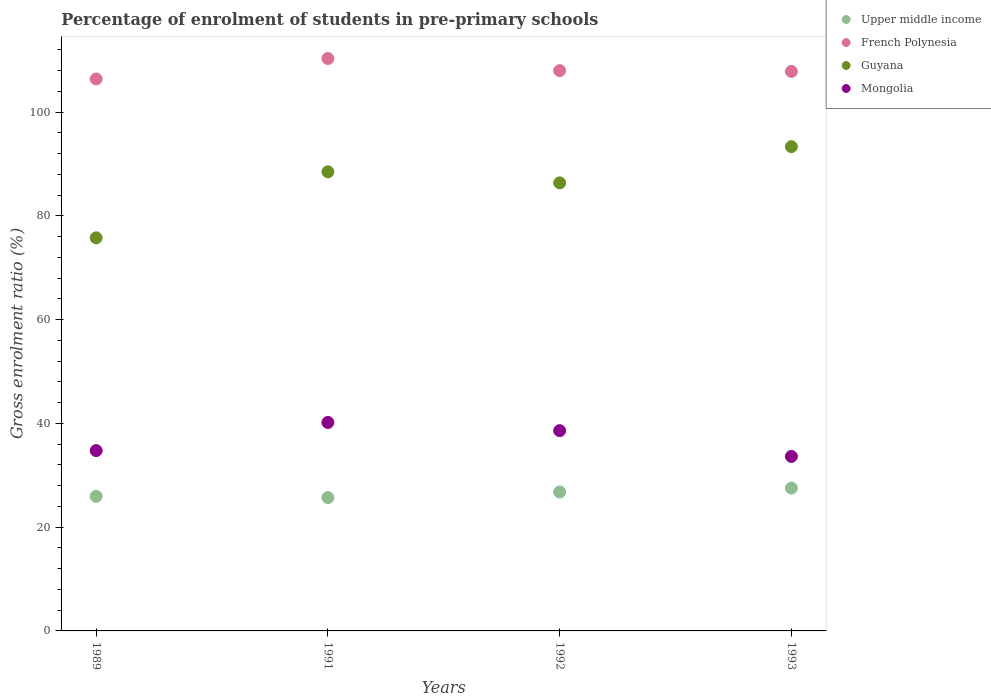How many different coloured dotlines are there?
Your answer should be compact. 4. Is the number of dotlines equal to the number of legend labels?
Your answer should be compact. Yes. What is the percentage of students enrolled in pre-primary schools in Upper middle income in 1989?
Offer a terse response. 25.94. Across all years, what is the maximum percentage of students enrolled in pre-primary schools in Upper middle income?
Ensure brevity in your answer.  27.53. Across all years, what is the minimum percentage of students enrolled in pre-primary schools in Guyana?
Provide a short and direct response. 75.77. In which year was the percentage of students enrolled in pre-primary schools in French Polynesia maximum?
Give a very brief answer. 1991. In which year was the percentage of students enrolled in pre-primary schools in French Polynesia minimum?
Make the answer very short. 1989. What is the total percentage of students enrolled in pre-primary schools in Upper middle income in the graph?
Your answer should be very brief. 105.95. What is the difference between the percentage of students enrolled in pre-primary schools in Upper middle income in 1991 and that in 1993?
Make the answer very short. -1.82. What is the difference between the percentage of students enrolled in pre-primary schools in Mongolia in 1993 and the percentage of students enrolled in pre-primary schools in Guyana in 1992?
Your response must be concise. -52.72. What is the average percentage of students enrolled in pre-primary schools in French Polynesia per year?
Your response must be concise. 108.14. In the year 1989, what is the difference between the percentage of students enrolled in pre-primary schools in French Polynesia and percentage of students enrolled in pre-primary schools in Guyana?
Ensure brevity in your answer.  30.62. In how many years, is the percentage of students enrolled in pre-primary schools in Guyana greater than 52 %?
Offer a very short reply. 4. What is the ratio of the percentage of students enrolled in pre-primary schools in Guyana in 1991 to that in 1993?
Provide a succinct answer. 0.95. What is the difference between the highest and the second highest percentage of students enrolled in pre-primary schools in Mongolia?
Your answer should be very brief. 1.58. What is the difference between the highest and the lowest percentage of students enrolled in pre-primary schools in French Polynesia?
Provide a succinct answer. 3.94. In how many years, is the percentage of students enrolled in pre-primary schools in Mongolia greater than the average percentage of students enrolled in pre-primary schools in Mongolia taken over all years?
Provide a succinct answer. 2. Is the sum of the percentage of students enrolled in pre-primary schools in Guyana in 1989 and 1991 greater than the maximum percentage of students enrolled in pre-primary schools in French Polynesia across all years?
Give a very brief answer. Yes. Does the percentage of students enrolled in pre-primary schools in French Polynesia monotonically increase over the years?
Give a very brief answer. No. How many years are there in the graph?
Offer a terse response. 4. What is the difference between two consecutive major ticks on the Y-axis?
Your response must be concise. 20. Are the values on the major ticks of Y-axis written in scientific E-notation?
Provide a succinct answer. No. How are the legend labels stacked?
Offer a terse response. Vertical. What is the title of the graph?
Provide a short and direct response. Percentage of enrolment of students in pre-primary schools. What is the Gross enrolment ratio (%) of Upper middle income in 1989?
Give a very brief answer. 25.94. What is the Gross enrolment ratio (%) in French Polynesia in 1989?
Provide a succinct answer. 106.39. What is the Gross enrolment ratio (%) in Guyana in 1989?
Your answer should be very brief. 75.77. What is the Gross enrolment ratio (%) of Mongolia in 1989?
Your answer should be compact. 34.76. What is the Gross enrolment ratio (%) in Upper middle income in 1991?
Offer a terse response. 25.71. What is the Gross enrolment ratio (%) of French Polynesia in 1991?
Your answer should be compact. 110.33. What is the Gross enrolment ratio (%) in Guyana in 1991?
Offer a terse response. 88.49. What is the Gross enrolment ratio (%) of Mongolia in 1991?
Make the answer very short. 40.18. What is the Gross enrolment ratio (%) in Upper middle income in 1992?
Your answer should be compact. 26.78. What is the Gross enrolment ratio (%) of French Polynesia in 1992?
Provide a short and direct response. 108. What is the Gross enrolment ratio (%) in Guyana in 1992?
Your answer should be very brief. 86.36. What is the Gross enrolment ratio (%) of Mongolia in 1992?
Provide a succinct answer. 38.6. What is the Gross enrolment ratio (%) in Upper middle income in 1993?
Your answer should be compact. 27.53. What is the Gross enrolment ratio (%) in French Polynesia in 1993?
Offer a very short reply. 107.84. What is the Gross enrolment ratio (%) in Guyana in 1993?
Provide a short and direct response. 93.34. What is the Gross enrolment ratio (%) in Mongolia in 1993?
Give a very brief answer. 33.64. Across all years, what is the maximum Gross enrolment ratio (%) of Upper middle income?
Make the answer very short. 27.53. Across all years, what is the maximum Gross enrolment ratio (%) in French Polynesia?
Your response must be concise. 110.33. Across all years, what is the maximum Gross enrolment ratio (%) in Guyana?
Make the answer very short. 93.34. Across all years, what is the maximum Gross enrolment ratio (%) of Mongolia?
Offer a very short reply. 40.18. Across all years, what is the minimum Gross enrolment ratio (%) of Upper middle income?
Provide a short and direct response. 25.71. Across all years, what is the minimum Gross enrolment ratio (%) in French Polynesia?
Your response must be concise. 106.39. Across all years, what is the minimum Gross enrolment ratio (%) in Guyana?
Give a very brief answer. 75.77. Across all years, what is the minimum Gross enrolment ratio (%) in Mongolia?
Ensure brevity in your answer.  33.64. What is the total Gross enrolment ratio (%) in Upper middle income in the graph?
Your response must be concise. 105.95. What is the total Gross enrolment ratio (%) of French Polynesia in the graph?
Your response must be concise. 432.56. What is the total Gross enrolment ratio (%) in Guyana in the graph?
Your answer should be very brief. 343.96. What is the total Gross enrolment ratio (%) of Mongolia in the graph?
Ensure brevity in your answer.  147.18. What is the difference between the Gross enrolment ratio (%) of Upper middle income in 1989 and that in 1991?
Your answer should be compact. 0.23. What is the difference between the Gross enrolment ratio (%) of French Polynesia in 1989 and that in 1991?
Your answer should be compact. -3.94. What is the difference between the Gross enrolment ratio (%) in Guyana in 1989 and that in 1991?
Provide a succinct answer. -12.72. What is the difference between the Gross enrolment ratio (%) of Mongolia in 1989 and that in 1991?
Ensure brevity in your answer.  -5.42. What is the difference between the Gross enrolment ratio (%) in Upper middle income in 1989 and that in 1992?
Ensure brevity in your answer.  -0.84. What is the difference between the Gross enrolment ratio (%) of French Polynesia in 1989 and that in 1992?
Ensure brevity in your answer.  -1.61. What is the difference between the Gross enrolment ratio (%) of Guyana in 1989 and that in 1992?
Give a very brief answer. -10.59. What is the difference between the Gross enrolment ratio (%) in Mongolia in 1989 and that in 1992?
Ensure brevity in your answer.  -3.84. What is the difference between the Gross enrolment ratio (%) of Upper middle income in 1989 and that in 1993?
Offer a terse response. -1.59. What is the difference between the Gross enrolment ratio (%) in French Polynesia in 1989 and that in 1993?
Your response must be concise. -1.46. What is the difference between the Gross enrolment ratio (%) in Guyana in 1989 and that in 1993?
Provide a short and direct response. -17.57. What is the difference between the Gross enrolment ratio (%) in Mongolia in 1989 and that in 1993?
Keep it short and to the point. 1.12. What is the difference between the Gross enrolment ratio (%) in Upper middle income in 1991 and that in 1992?
Provide a succinct answer. -1.07. What is the difference between the Gross enrolment ratio (%) of French Polynesia in 1991 and that in 1992?
Offer a very short reply. 2.33. What is the difference between the Gross enrolment ratio (%) in Guyana in 1991 and that in 1992?
Offer a terse response. 2.13. What is the difference between the Gross enrolment ratio (%) in Mongolia in 1991 and that in 1992?
Keep it short and to the point. 1.58. What is the difference between the Gross enrolment ratio (%) of Upper middle income in 1991 and that in 1993?
Your response must be concise. -1.82. What is the difference between the Gross enrolment ratio (%) in French Polynesia in 1991 and that in 1993?
Provide a short and direct response. 2.49. What is the difference between the Gross enrolment ratio (%) of Guyana in 1991 and that in 1993?
Provide a short and direct response. -4.85. What is the difference between the Gross enrolment ratio (%) of Mongolia in 1991 and that in 1993?
Offer a very short reply. 6.54. What is the difference between the Gross enrolment ratio (%) of Upper middle income in 1992 and that in 1993?
Give a very brief answer. -0.75. What is the difference between the Gross enrolment ratio (%) in French Polynesia in 1992 and that in 1993?
Keep it short and to the point. 0.16. What is the difference between the Gross enrolment ratio (%) of Guyana in 1992 and that in 1993?
Ensure brevity in your answer.  -6.98. What is the difference between the Gross enrolment ratio (%) of Mongolia in 1992 and that in 1993?
Provide a succinct answer. 4.97. What is the difference between the Gross enrolment ratio (%) of Upper middle income in 1989 and the Gross enrolment ratio (%) of French Polynesia in 1991?
Offer a very short reply. -84.39. What is the difference between the Gross enrolment ratio (%) of Upper middle income in 1989 and the Gross enrolment ratio (%) of Guyana in 1991?
Your answer should be very brief. -62.55. What is the difference between the Gross enrolment ratio (%) in Upper middle income in 1989 and the Gross enrolment ratio (%) in Mongolia in 1991?
Your answer should be very brief. -14.24. What is the difference between the Gross enrolment ratio (%) in French Polynesia in 1989 and the Gross enrolment ratio (%) in Guyana in 1991?
Offer a very short reply. 17.89. What is the difference between the Gross enrolment ratio (%) in French Polynesia in 1989 and the Gross enrolment ratio (%) in Mongolia in 1991?
Give a very brief answer. 66.21. What is the difference between the Gross enrolment ratio (%) of Guyana in 1989 and the Gross enrolment ratio (%) of Mongolia in 1991?
Your answer should be very brief. 35.59. What is the difference between the Gross enrolment ratio (%) in Upper middle income in 1989 and the Gross enrolment ratio (%) in French Polynesia in 1992?
Give a very brief answer. -82.06. What is the difference between the Gross enrolment ratio (%) in Upper middle income in 1989 and the Gross enrolment ratio (%) in Guyana in 1992?
Offer a very short reply. -60.42. What is the difference between the Gross enrolment ratio (%) of Upper middle income in 1989 and the Gross enrolment ratio (%) of Mongolia in 1992?
Give a very brief answer. -12.66. What is the difference between the Gross enrolment ratio (%) of French Polynesia in 1989 and the Gross enrolment ratio (%) of Guyana in 1992?
Your answer should be very brief. 20.03. What is the difference between the Gross enrolment ratio (%) of French Polynesia in 1989 and the Gross enrolment ratio (%) of Mongolia in 1992?
Your response must be concise. 67.79. What is the difference between the Gross enrolment ratio (%) of Guyana in 1989 and the Gross enrolment ratio (%) of Mongolia in 1992?
Ensure brevity in your answer.  37.17. What is the difference between the Gross enrolment ratio (%) of Upper middle income in 1989 and the Gross enrolment ratio (%) of French Polynesia in 1993?
Provide a short and direct response. -81.9. What is the difference between the Gross enrolment ratio (%) of Upper middle income in 1989 and the Gross enrolment ratio (%) of Guyana in 1993?
Provide a succinct answer. -67.4. What is the difference between the Gross enrolment ratio (%) of Upper middle income in 1989 and the Gross enrolment ratio (%) of Mongolia in 1993?
Provide a succinct answer. -7.7. What is the difference between the Gross enrolment ratio (%) in French Polynesia in 1989 and the Gross enrolment ratio (%) in Guyana in 1993?
Make the answer very short. 13.05. What is the difference between the Gross enrolment ratio (%) in French Polynesia in 1989 and the Gross enrolment ratio (%) in Mongolia in 1993?
Provide a succinct answer. 72.75. What is the difference between the Gross enrolment ratio (%) in Guyana in 1989 and the Gross enrolment ratio (%) in Mongolia in 1993?
Offer a terse response. 42.13. What is the difference between the Gross enrolment ratio (%) in Upper middle income in 1991 and the Gross enrolment ratio (%) in French Polynesia in 1992?
Your answer should be very brief. -82.29. What is the difference between the Gross enrolment ratio (%) of Upper middle income in 1991 and the Gross enrolment ratio (%) of Guyana in 1992?
Provide a short and direct response. -60.65. What is the difference between the Gross enrolment ratio (%) in Upper middle income in 1991 and the Gross enrolment ratio (%) in Mongolia in 1992?
Your answer should be very brief. -12.9. What is the difference between the Gross enrolment ratio (%) of French Polynesia in 1991 and the Gross enrolment ratio (%) of Guyana in 1992?
Ensure brevity in your answer.  23.97. What is the difference between the Gross enrolment ratio (%) in French Polynesia in 1991 and the Gross enrolment ratio (%) in Mongolia in 1992?
Ensure brevity in your answer.  71.73. What is the difference between the Gross enrolment ratio (%) in Guyana in 1991 and the Gross enrolment ratio (%) in Mongolia in 1992?
Ensure brevity in your answer.  49.89. What is the difference between the Gross enrolment ratio (%) of Upper middle income in 1991 and the Gross enrolment ratio (%) of French Polynesia in 1993?
Offer a terse response. -82.14. What is the difference between the Gross enrolment ratio (%) in Upper middle income in 1991 and the Gross enrolment ratio (%) in Guyana in 1993?
Ensure brevity in your answer.  -67.64. What is the difference between the Gross enrolment ratio (%) of Upper middle income in 1991 and the Gross enrolment ratio (%) of Mongolia in 1993?
Offer a terse response. -7.93. What is the difference between the Gross enrolment ratio (%) of French Polynesia in 1991 and the Gross enrolment ratio (%) of Guyana in 1993?
Make the answer very short. 16.99. What is the difference between the Gross enrolment ratio (%) of French Polynesia in 1991 and the Gross enrolment ratio (%) of Mongolia in 1993?
Your answer should be very brief. 76.69. What is the difference between the Gross enrolment ratio (%) of Guyana in 1991 and the Gross enrolment ratio (%) of Mongolia in 1993?
Your answer should be very brief. 54.86. What is the difference between the Gross enrolment ratio (%) of Upper middle income in 1992 and the Gross enrolment ratio (%) of French Polynesia in 1993?
Offer a very short reply. -81.07. What is the difference between the Gross enrolment ratio (%) in Upper middle income in 1992 and the Gross enrolment ratio (%) in Guyana in 1993?
Your answer should be compact. -66.56. What is the difference between the Gross enrolment ratio (%) in Upper middle income in 1992 and the Gross enrolment ratio (%) in Mongolia in 1993?
Your answer should be very brief. -6.86. What is the difference between the Gross enrolment ratio (%) in French Polynesia in 1992 and the Gross enrolment ratio (%) in Guyana in 1993?
Keep it short and to the point. 14.66. What is the difference between the Gross enrolment ratio (%) in French Polynesia in 1992 and the Gross enrolment ratio (%) in Mongolia in 1993?
Provide a short and direct response. 74.36. What is the difference between the Gross enrolment ratio (%) in Guyana in 1992 and the Gross enrolment ratio (%) in Mongolia in 1993?
Your answer should be very brief. 52.72. What is the average Gross enrolment ratio (%) of Upper middle income per year?
Keep it short and to the point. 26.49. What is the average Gross enrolment ratio (%) in French Polynesia per year?
Offer a very short reply. 108.14. What is the average Gross enrolment ratio (%) in Guyana per year?
Your answer should be compact. 85.99. What is the average Gross enrolment ratio (%) of Mongolia per year?
Make the answer very short. 36.79. In the year 1989, what is the difference between the Gross enrolment ratio (%) in Upper middle income and Gross enrolment ratio (%) in French Polynesia?
Provide a short and direct response. -80.45. In the year 1989, what is the difference between the Gross enrolment ratio (%) in Upper middle income and Gross enrolment ratio (%) in Guyana?
Ensure brevity in your answer.  -49.83. In the year 1989, what is the difference between the Gross enrolment ratio (%) in Upper middle income and Gross enrolment ratio (%) in Mongolia?
Provide a succinct answer. -8.82. In the year 1989, what is the difference between the Gross enrolment ratio (%) in French Polynesia and Gross enrolment ratio (%) in Guyana?
Ensure brevity in your answer.  30.62. In the year 1989, what is the difference between the Gross enrolment ratio (%) in French Polynesia and Gross enrolment ratio (%) in Mongolia?
Make the answer very short. 71.63. In the year 1989, what is the difference between the Gross enrolment ratio (%) in Guyana and Gross enrolment ratio (%) in Mongolia?
Your answer should be compact. 41.01. In the year 1991, what is the difference between the Gross enrolment ratio (%) of Upper middle income and Gross enrolment ratio (%) of French Polynesia?
Ensure brevity in your answer.  -84.63. In the year 1991, what is the difference between the Gross enrolment ratio (%) in Upper middle income and Gross enrolment ratio (%) in Guyana?
Provide a short and direct response. -62.79. In the year 1991, what is the difference between the Gross enrolment ratio (%) of Upper middle income and Gross enrolment ratio (%) of Mongolia?
Your response must be concise. -14.47. In the year 1991, what is the difference between the Gross enrolment ratio (%) of French Polynesia and Gross enrolment ratio (%) of Guyana?
Keep it short and to the point. 21.84. In the year 1991, what is the difference between the Gross enrolment ratio (%) in French Polynesia and Gross enrolment ratio (%) in Mongolia?
Your answer should be very brief. 70.15. In the year 1991, what is the difference between the Gross enrolment ratio (%) in Guyana and Gross enrolment ratio (%) in Mongolia?
Provide a short and direct response. 48.31. In the year 1992, what is the difference between the Gross enrolment ratio (%) of Upper middle income and Gross enrolment ratio (%) of French Polynesia?
Ensure brevity in your answer.  -81.22. In the year 1992, what is the difference between the Gross enrolment ratio (%) in Upper middle income and Gross enrolment ratio (%) in Guyana?
Your response must be concise. -59.58. In the year 1992, what is the difference between the Gross enrolment ratio (%) of Upper middle income and Gross enrolment ratio (%) of Mongolia?
Your answer should be compact. -11.82. In the year 1992, what is the difference between the Gross enrolment ratio (%) of French Polynesia and Gross enrolment ratio (%) of Guyana?
Your answer should be very brief. 21.64. In the year 1992, what is the difference between the Gross enrolment ratio (%) of French Polynesia and Gross enrolment ratio (%) of Mongolia?
Provide a succinct answer. 69.4. In the year 1992, what is the difference between the Gross enrolment ratio (%) of Guyana and Gross enrolment ratio (%) of Mongolia?
Your answer should be very brief. 47.76. In the year 1993, what is the difference between the Gross enrolment ratio (%) in Upper middle income and Gross enrolment ratio (%) in French Polynesia?
Ensure brevity in your answer.  -80.31. In the year 1993, what is the difference between the Gross enrolment ratio (%) in Upper middle income and Gross enrolment ratio (%) in Guyana?
Provide a succinct answer. -65.81. In the year 1993, what is the difference between the Gross enrolment ratio (%) in Upper middle income and Gross enrolment ratio (%) in Mongolia?
Your response must be concise. -6.11. In the year 1993, what is the difference between the Gross enrolment ratio (%) of French Polynesia and Gross enrolment ratio (%) of Guyana?
Your answer should be very brief. 14.5. In the year 1993, what is the difference between the Gross enrolment ratio (%) in French Polynesia and Gross enrolment ratio (%) in Mongolia?
Your answer should be compact. 74.21. In the year 1993, what is the difference between the Gross enrolment ratio (%) in Guyana and Gross enrolment ratio (%) in Mongolia?
Provide a short and direct response. 59.7. What is the ratio of the Gross enrolment ratio (%) in Upper middle income in 1989 to that in 1991?
Keep it short and to the point. 1.01. What is the ratio of the Gross enrolment ratio (%) of French Polynesia in 1989 to that in 1991?
Give a very brief answer. 0.96. What is the ratio of the Gross enrolment ratio (%) in Guyana in 1989 to that in 1991?
Ensure brevity in your answer.  0.86. What is the ratio of the Gross enrolment ratio (%) of Mongolia in 1989 to that in 1991?
Offer a very short reply. 0.87. What is the ratio of the Gross enrolment ratio (%) of Upper middle income in 1989 to that in 1992?
Provide a succinct answer. 0.97. What is the ratio of the Gross enrolment ratio (%) in French Polynesia in 1989 to that in 1992?
Ensure brevity in your answer.  0.99. What is the ratio of the Gross enrolment ratio (%) of Guyana in 1989 to that in 1992?
Provide a succinct answer. 0.88. What is the ratio of the Gross enrolment ratio (%) of Mongolia in 1989 to that in 1992?
Your answer should be very brief. 0.9. What is the ratio of the Gross enrolment ratio (%) in Upper middle income in 1989 to that in 1993?
Provide a short and direct response. 0.94. What is the ratio of the Gross enrolment ratio (%) in French Polynesia in 1989 to that in 1993?
Make the answer very short. 0.99. What is the ratio of the Gross enrolment ratio (%) in Guyana in 1989 to that in 1993?
Keep it short and to the point. 0.81. What is the ratio of the Gross enrolment ratio (%) of Mongolia in 1989 to that in 1993?
Offer a terse response. 1.03. What is the ratio of the Gross enrolment ratio (%) of Upper middle income in 1991 to that in 1992?
Your answer should be very brief. 0.96. What is the ratio of the Gross enrolment ratio (%) in French Polynesia in 1991 to that in 1992?
Keep it short and to the point. 1.02. What is the ratio of the Gross enrolment ratio (%) of Guyana in 1991 to that in 1992?
Make the answer very short. 1.02. What is the ratio of the Gross enrolment ratio (%) of Mongolia in 1991 to that in 1992?
Provide a succinct answer. 1.04. What is the ratio of the Gross enrolment ratio (%) in Upper middle income in 1991 to that in 1993?
Your answer should be compact. 0.93. What is the ratio of the Gross enrolment ratio (%) in French Polynesia in 1991 to that in 1993?
Ensure brevity in your answer.  1.02. What is the ratio of the Gross enrolment ratio (%) in Guyana in 1991 to that in 1993?
Provide a succinct answer. 0.95. What is the ratio of the Gross enrolment ratio (%) in Mongolia in 1991 to that in 1993?
Make the answer very short. 1.19. What is the ratio of the Gross enrolment ratio (%) of Upper middle income in 1992 to that in 1993?
Make the answer very short. 0.97. What is the ratio of the Gross enrolment ratio (%) of Guyana in 1992 to that in 1993?
Your answer should be very brief. 0.93. What is the ratio of the Gross enrolment ratio (%) of Mongolia in 1992 to that in 1993?
Give a very brief answer. 1.15. What is the difference between the highest and the second highest Gross enrolment ratio (%) in Upper middle income?
Ensure brevity in your answer.  0.75. What is the difference between the highest and the second highest Gross enrolment ratio (%) in French Polynesia?
Give a very brief answer. 2.33. What is the difference between the highest and the second highest Gross enrolment ratio (%) of Guyana?
Make the answer very short. 4.85. What is the difference between the highest and the second highest Gross enrolment ratio (%) of Mongolia?
Offer a terse response. 1.58. What is the difference between the highest and the lowest Gross enrolment ratio (%) of Upper middle income?
Your answer should be very brief. 1.82. What is the difference between the highest and the lowest Gross enrolment ratio (%) in French Polynesia?
Your answer should be compact. 3.94. What is the difference between the highest and the lowest Gross enrolment ratio (%) in Guyana?
Offer a terse response. 17.57. What is the difference between the highest and the lowest Gross enrolment ratio (%) in Mongolia?
Your response must be concise. 6.54. 